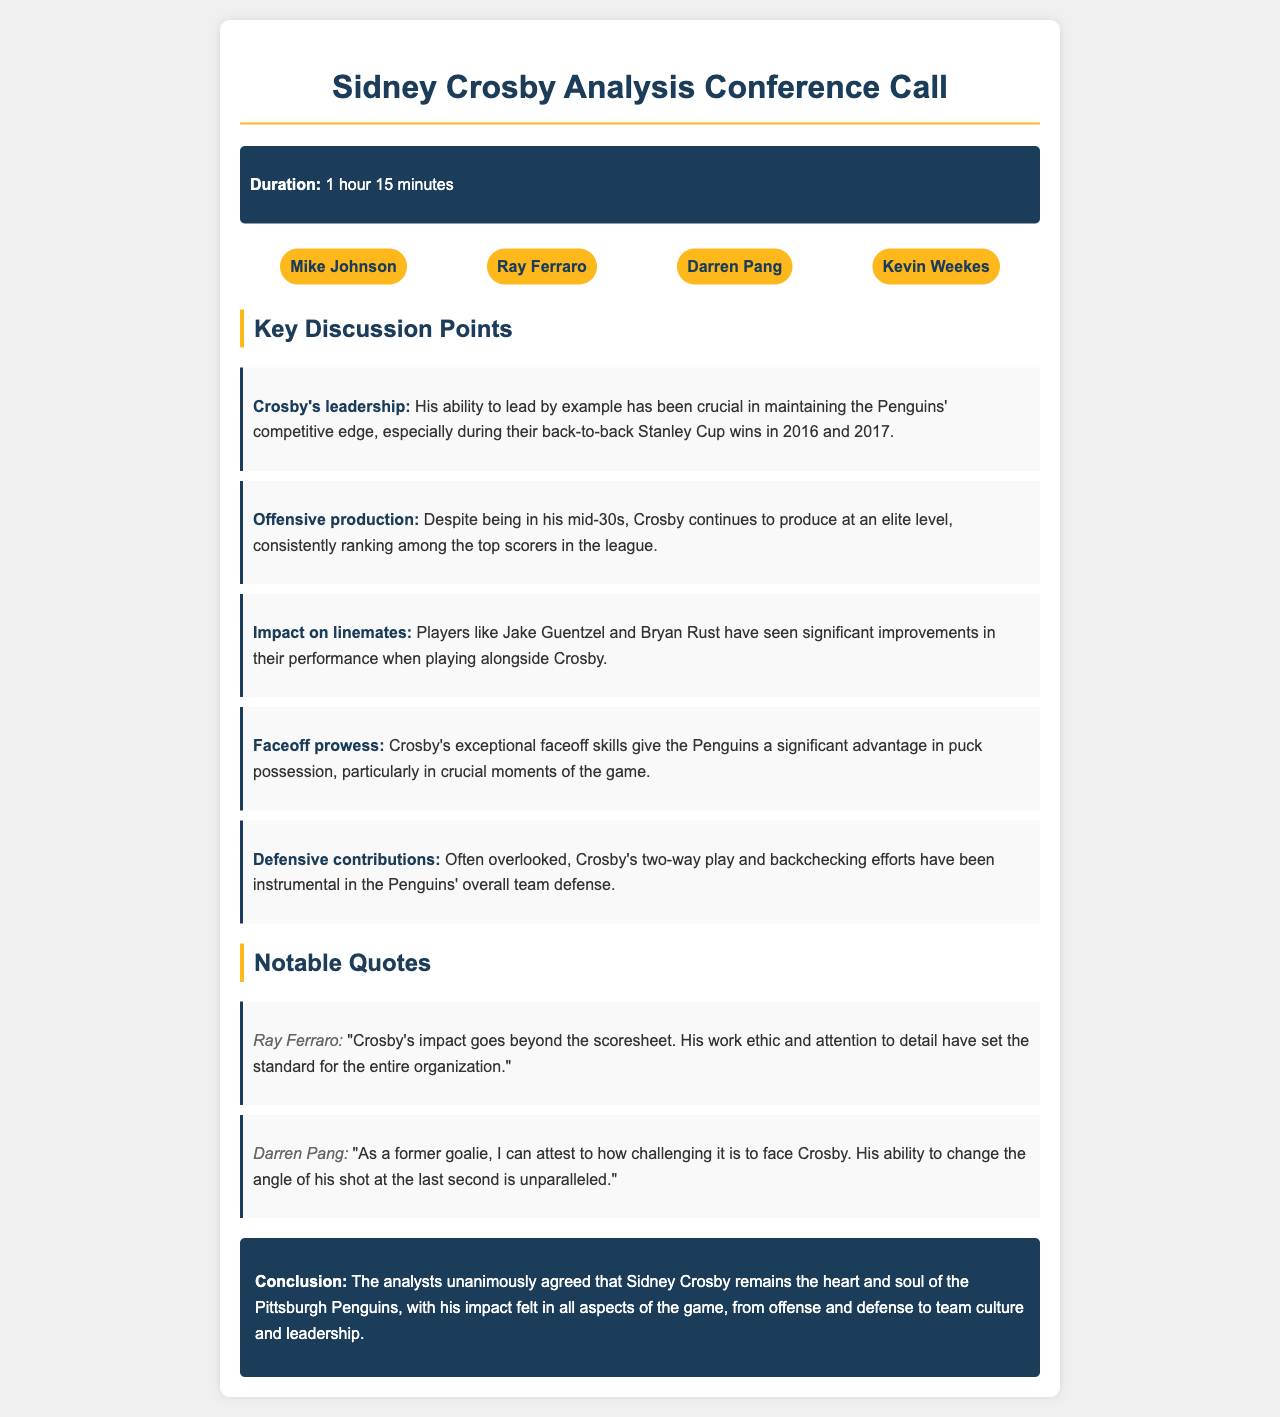What was the duration of the conference call? The duration of the conference call is explicitly stated in the document as 1 hour 15 minutes.
Answer: 1 hour 15 minutes Who mentioned Crosby's work ethic and attention to detail? Ray Ferraro is the analyst who made a notable quote regarding Crosby's impact, emphasizing his work ethic.
Answer: Ray Ferraro What significant advantage does Crosby provide regarding faceoffs? The discussion mentions that Crosby's exceptional faceoff skills give the Penguins a significant advantage in puck possession.
Answer: Significant advantage Which years did the Penguins win back-to-back Stanley Cups? The document states that Crosby's leadership was crucial during the Penguins' back-to-back Stanley Cup wins in 2016 and 2017.
Answer: 2016 and 2017 How many key discussion points are listed in the document? The discussion points section features five key points regarding Crosby's impact, which can be counted directly.
Answer: Five What is the overall conclusion about Sidney Crosby's role in the Penguins? The conclusion summarizes that Crosby is viewed as the heart and soul of the Penguins, impacting multiple facets of the game.
Answer: Heart and soul Which two players have improved while playing alongside Crosby? The document states that players Jake Guentzel and Bryan Rust have seen significant performance improvements alongside Crosby.
Answer: Jake Guentzel and Bryan Rust What aspect of Crosby's play is often overlooked? The discussion points mention that his contributions to defense, specifically two-way play and backchecking, are often overlooked.
Answer: Defensive contributions 